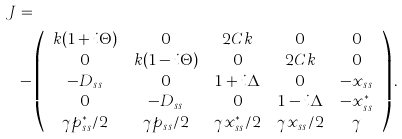Convert formula to latex. <formula><loc_0><loc_0><loc_500><loc_500>J & = \\ & - \left ( \begin{array} { c c c c c } k ( 1 + i \Theta ) & 0 & 2 C k & 0 & 0 \\ 0 & k ( 1 - i \Theta ) & 0 & 2 C k & 0 \\ - D _ { s s } & 0 & 1 + i \Delta & 0 & - x _ { s s } \\ 0 & - D _ { s s } & 0 & 1 - i \Delta & - x _ { s s } ^ { * } \\ \gamma p _ { s s } ^ { * } / 2 & \gamma p _ { s s } / 2 & \gamma x _ { s s } ^ { * } / 2 & \gamma x _ { s s } / 2 & \gamma \end{array} \right ) .</formula> 